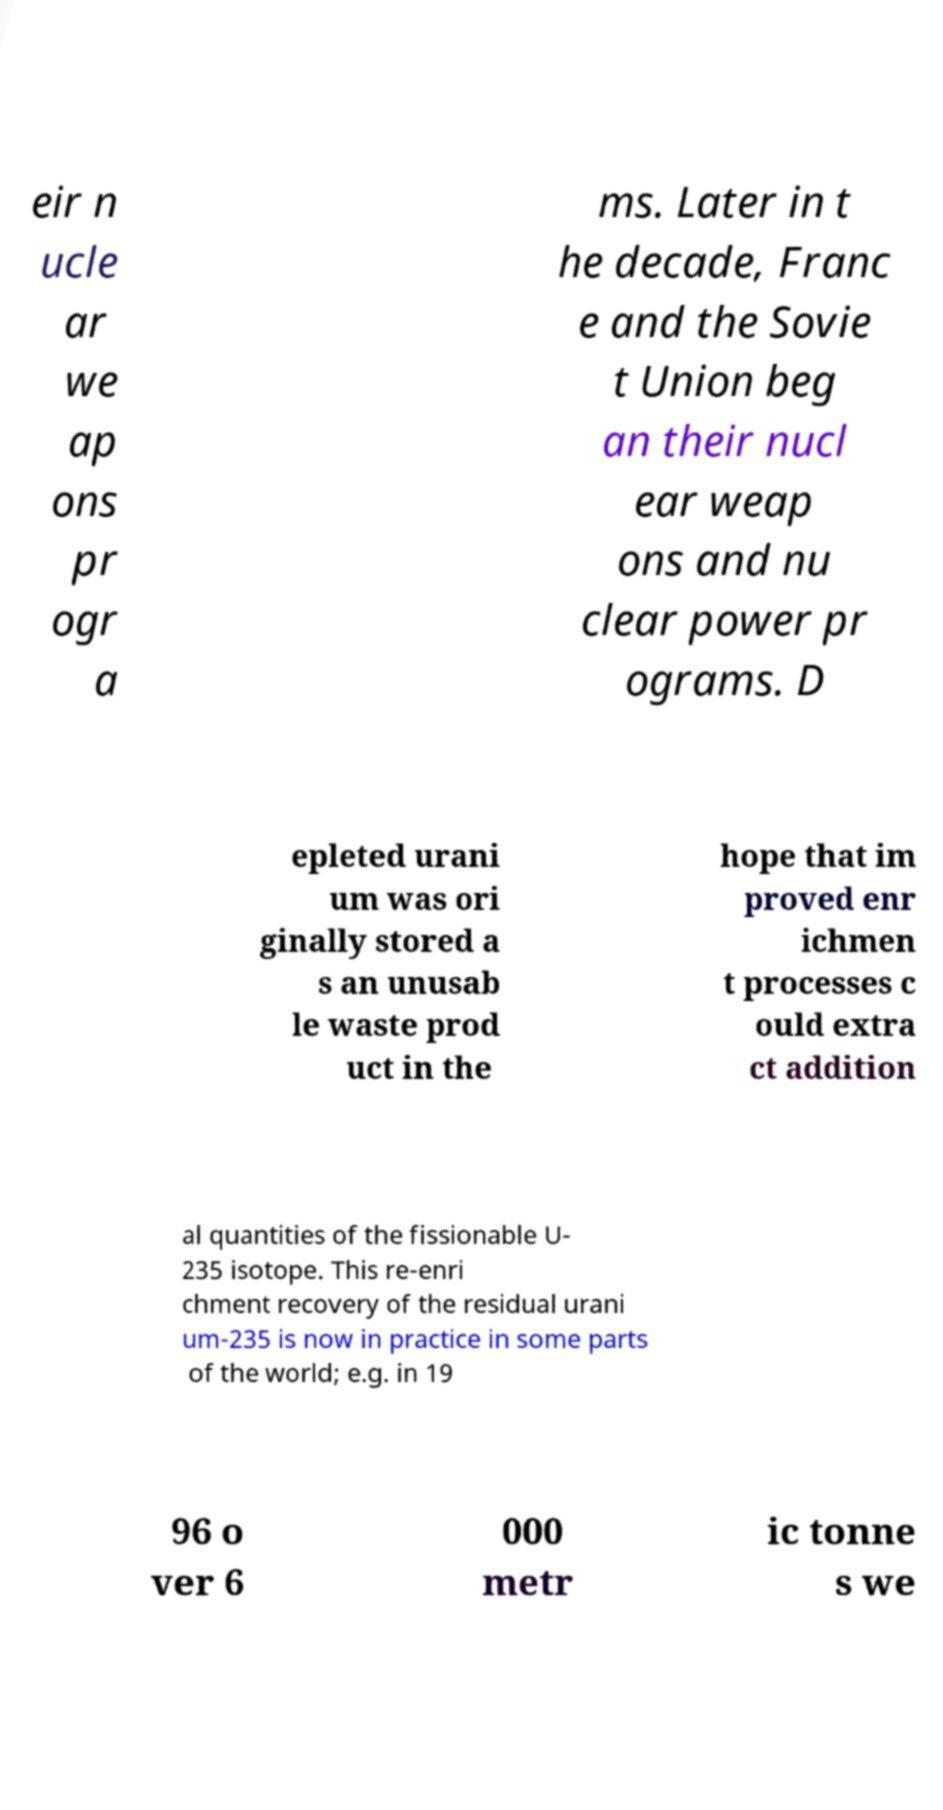What messages or text are displayed in this image? I need them in a readable, typed format. eir n ucle ar we ap ons pr ogr a ms. Later in t he decade, Franc e and the Sovie t Union beg an their nucl ear weap ons and nu clear power pr ograms. D epleted urani um was ori ginally stored a s an unusab le waste prod uct in the hope that im proved enr ichmen t processes c ould extra ct addition al quantities of the fissionable U- 235 isotope. This re-enri chment recovery of the residual urani um-235 is now in practice in some parts of the world; e.g. in 19 96 o ver 6 000 metr ic tonne s we 